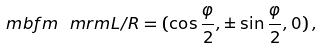Convert formula to latex. <formula><loc_0><loc_0><loc_500><loc_500>\ m b f { m } _ { \ } m r m { L / R } = ( \cos \frac { \varphi } { 2 } , \pm \sin \frac { \varphi } { 2 } , 0 ) \, ,</formula> 